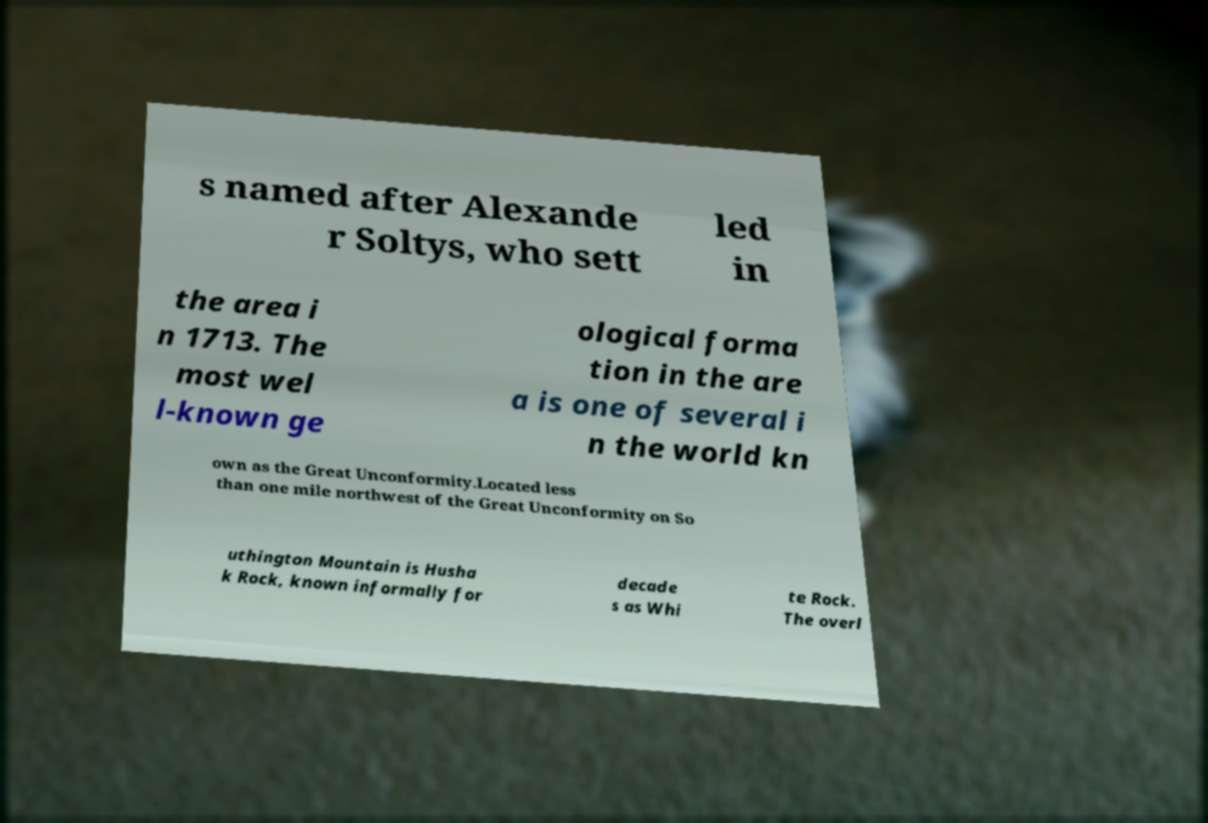Could you extract and type out the text from this image? s named after Alexande r Soltys, who sett led in the area i n 1713. The most wel l-known ge ological forma tion in the are a is one of several i n the world kn own as the Great Unconformity.Located less than one mile northwest of the Great Unconformity on So uthington Mountain is Husha k Rock, known informally for decade s as Whi te Rock. The overl 